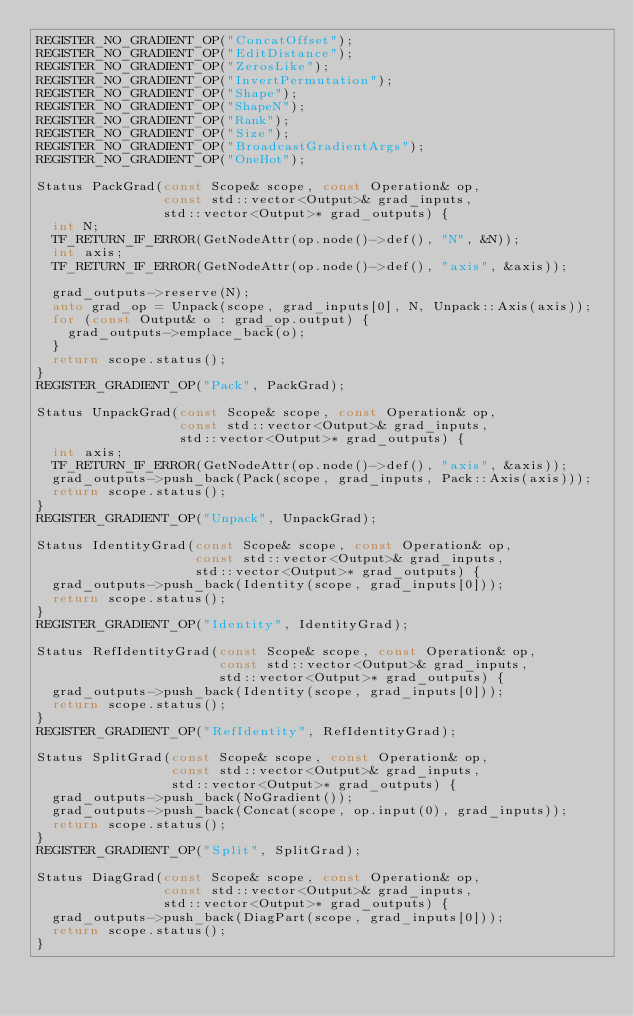<code> <loc_0><loc_0><loc_500><loc_500><_C++_>REGISTER_NO_GRADIENT_OP("ConcatOffset");
REGISTER_NO_GRADIENT_OP("EditDistance");
REGISTER_NO_GRADIENT_OP("ZerosLike");
REGISTER_NO_GRADIENT_OP("InvertPermutation");
REGISTER_NO_GRADIENT_OP("Shape");
REGISTER_NO_GRADIENT_OP("ShapeN");
REGISTER_NO_GRADIENT_OP("Rank");
REGISTER_NO_GRADIENT_OP("Size");
REGISTER_NO_GRADIENT_OP("BroadcastGradientArgs");
REGISTER_NO_GRADIENT_OP("OneHot");

Status PackGrad(const Scope& scope, const Operation& op,
                const std::vector<Output>& grad_inputs,
                std::vector<Output>* grad_outputs) {
  int N;
  TF_RETURN_IF_ERROR(GetNodeAttr(op.node()->def(), "N", &N));
  int axis;
  TF_RETURN_IF_ERROR(GetNodeAttr(op.node()->def(), "axis", &axis));

  grad_outputs->reserve(N);
  auto grad_op = Unpack(scope, grad_inputs[0], N, Unpack::Axis(axis));
  for (const Output& o : grad_op.output) {
    grad_outputs->emplace_back(o);
  }
  return scope.status();
}
REGISTER_GRADIENT_OP("Pack", PackGrad);

Status UnpackGrad(const Scope& scope, const Operation& op,
                  const std::vector<Output>& grad_inputs,
                  std::vector<Output>* grad_outputs) {
  int axis;
  TF_RETURN_IF_ERROR(GetNodeAttr(op.node()->def(), "axis", &axis));
  grad_outputs->push_back(Pack(scope, grad_inputs, Pack::Axis(axis)));
  return scope.status();
}
REGISTER_GRADIENT_OP("Unpack", UnpackGrad);

Status IdentityGrad(const Scope& scope, const Operation& op,
                    const std::vector<Output>& grad_inputs,
                    std::vector<Output>* grad_outputs) {
  grad_outputs->push_back(Identity(scope, grad_inputs[0]));
  return scope.status();
}
REGISTER_GRADIENT_OP("Identity", IdentityGrad);

Status RefIdentityGrad(const Scope& scope, const Operation& op,
                       const std::vector<Output>& grad_inputs,
                       std::vector<Output>* grad_outputs) {
  grad_outputs->push_back(Identity(scope, grad_inputs[0]));
  return scope.status();
}
REGISTER_GRADIENT_OP("RefIdentity", RefIdentityGrad);

Status SplitGrad(const Scope& scope, const Operation& op,
                 const std::vector<Output>& grad_inputs,
                 std::vector<Output>* grad_outputs) {
  grad_outputs->push_back(NoGradient());
  grad_outputs->push_back(Concat(scope, op.input(0), grad_inputs));
  return scope.status();
}
REGISTER_GRADIENT_OP("Split", SplitGrad);

Status DiagGrad(const Scope& scope, const Operation& op,
                const std::vector<Output>& grad_inputs,
                std::vector<Output>* grad_outputs) {
  grad_outputs->push_back(DiagPart(scope, grad_inputs[0]));
  return scope.status();
}</code> 